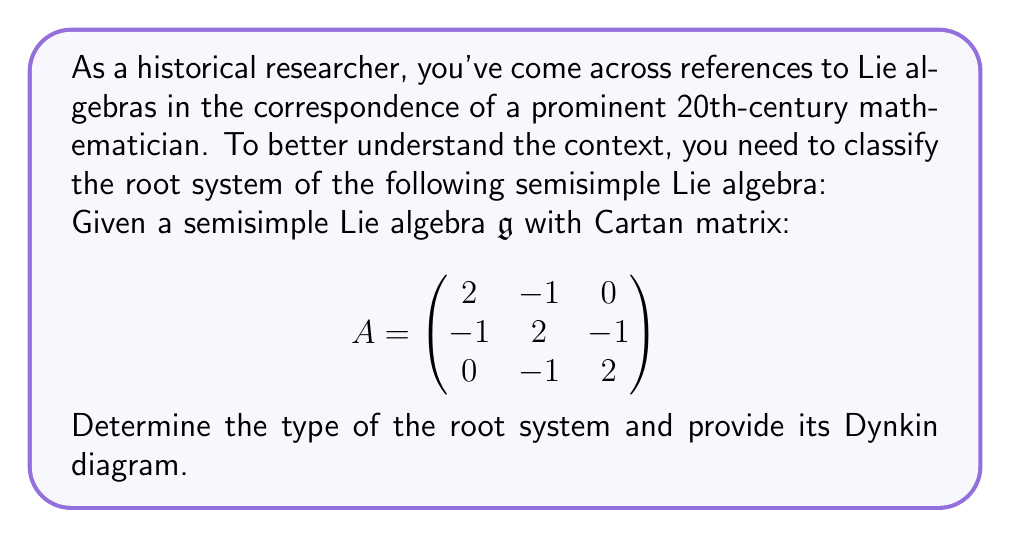Show me your answer to this math problem. To classify the root system of this semisimple Lie algebra, we'll follow these steps:

1) First, we need to analyze the Cartan matrix. The given matrix is:

$$ A = \begin{pmatrix}
2 & -1 & 0 \\
-1 & 2 & -1 \\
0 & -1 & 2
\end{pmatrix} $$

2) We observe that:
   - The diagonal elements are all 2
   - The off-diagonal elements are 0 or -1
   - The matrix is symmetric

These properties indicate that this is a valid Cartan matrix for a semisimple Lie algebra.

3) The next step is to count the number of rows (or columns) in the Cartan matrix. Here, we have a 3x3 matrix, indicating that the rank of the Lie algebra is 3.

4) Now, we need to look at the pattern of connections in the matrix. We can represent this as a graph where:
   - Each row/column represents a node
   - An edge connects two nodes if the corresponding off-diagonal element is non-zero

5) In this case, we have:
   - Node 1 connected to Node 2
   - Node 2 connected to Node 3
   - No direct connection between Node 1 and Node 3

6) This linear pattern with 3 nodes corresponds to the $A_3$ Dynkin diagram.

7) The Dynkin diagram for $A_3$ looks like this:

[asy]
unitsize(1cm);
dot((0,0)); dot((1,0)); dot((2,0));
draw((0,0)--(2,0));
label("1", (0,-0.5));
label("2", (1,-0.5));
label("3", (2,-0.5));
[/asy]

8) The $A_3$ root system corresponds to the Lie algebra $\mathfrak{sl}(4,\mathbb{C})$, which is the special linear algebra of 4x4 complex matrices with trace zero.
Answer: The root system of the given semisimple Lie algebra is of type $A_3$, corresponding to the Lie algebra $\mathfrak{sl}(4,\mathbb{C})$. 